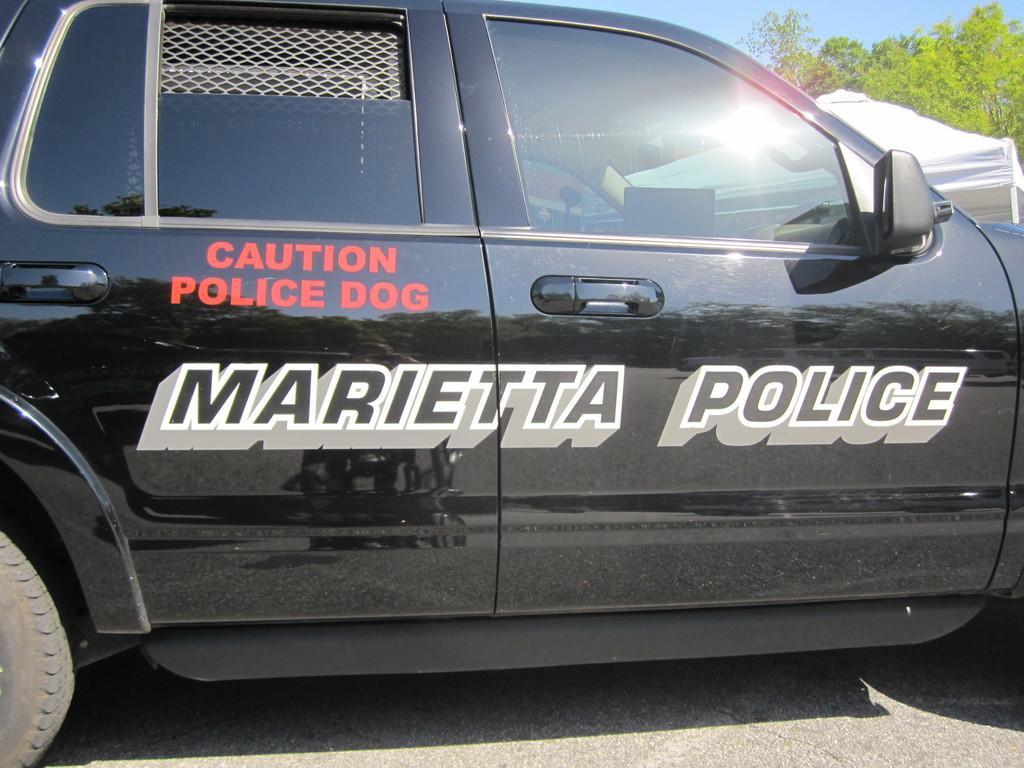In one or two sentences, can you explain what this image depicts? There is a zoom-in picture of a black color car we can see there is some text written on it. There is a white color tint and some trees are present at the top right corner of this image. 